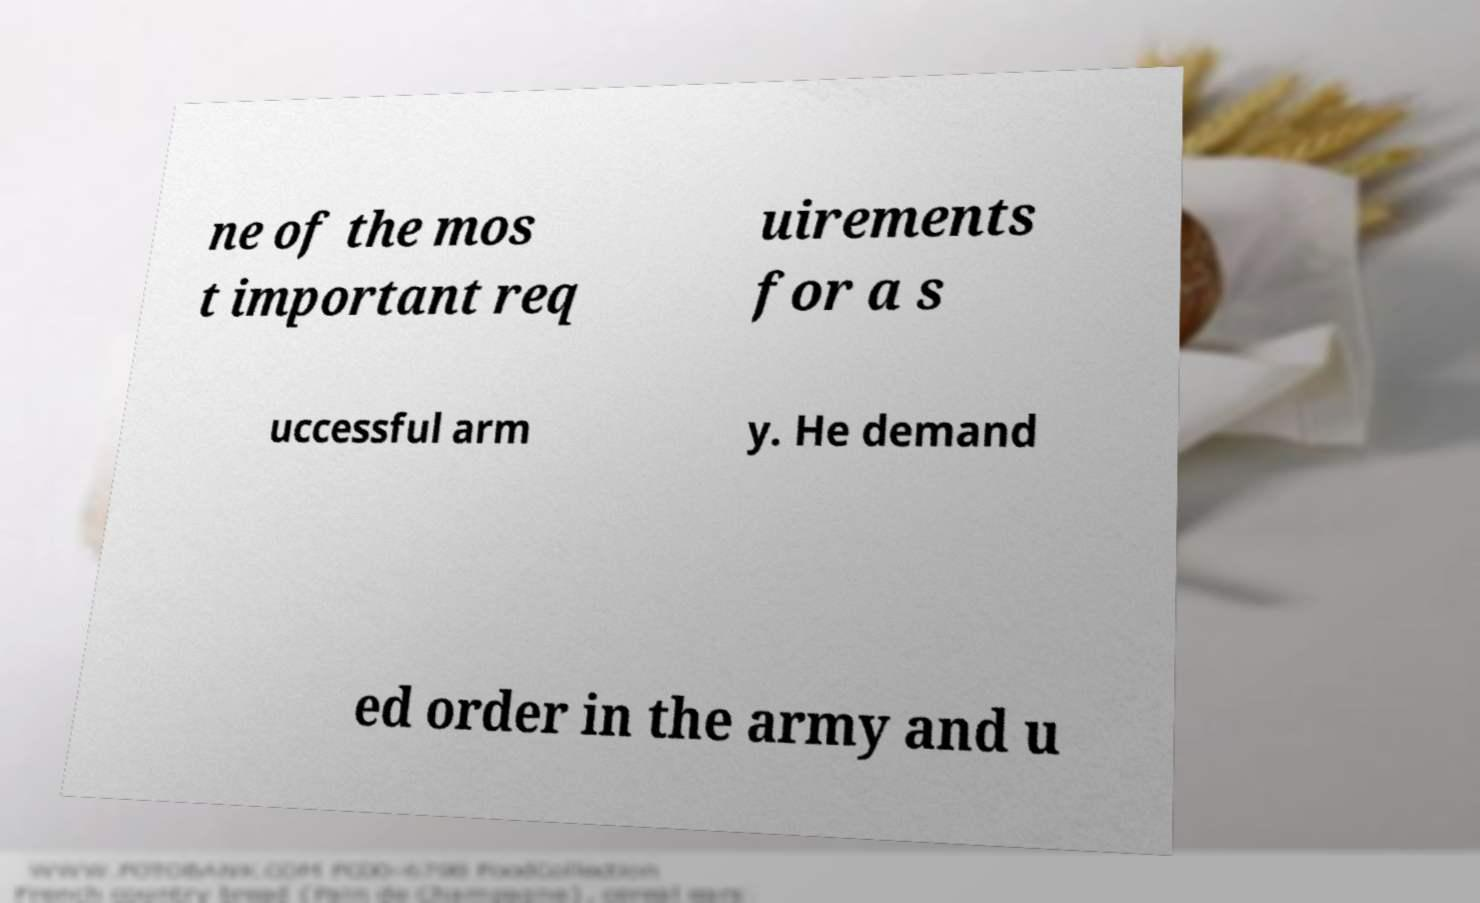What messages or text are displayed in this image? I need them in a readable, typed format. ne of the mos t important req uirements for a s uccessful arm y. He demand ed order in the army and u 